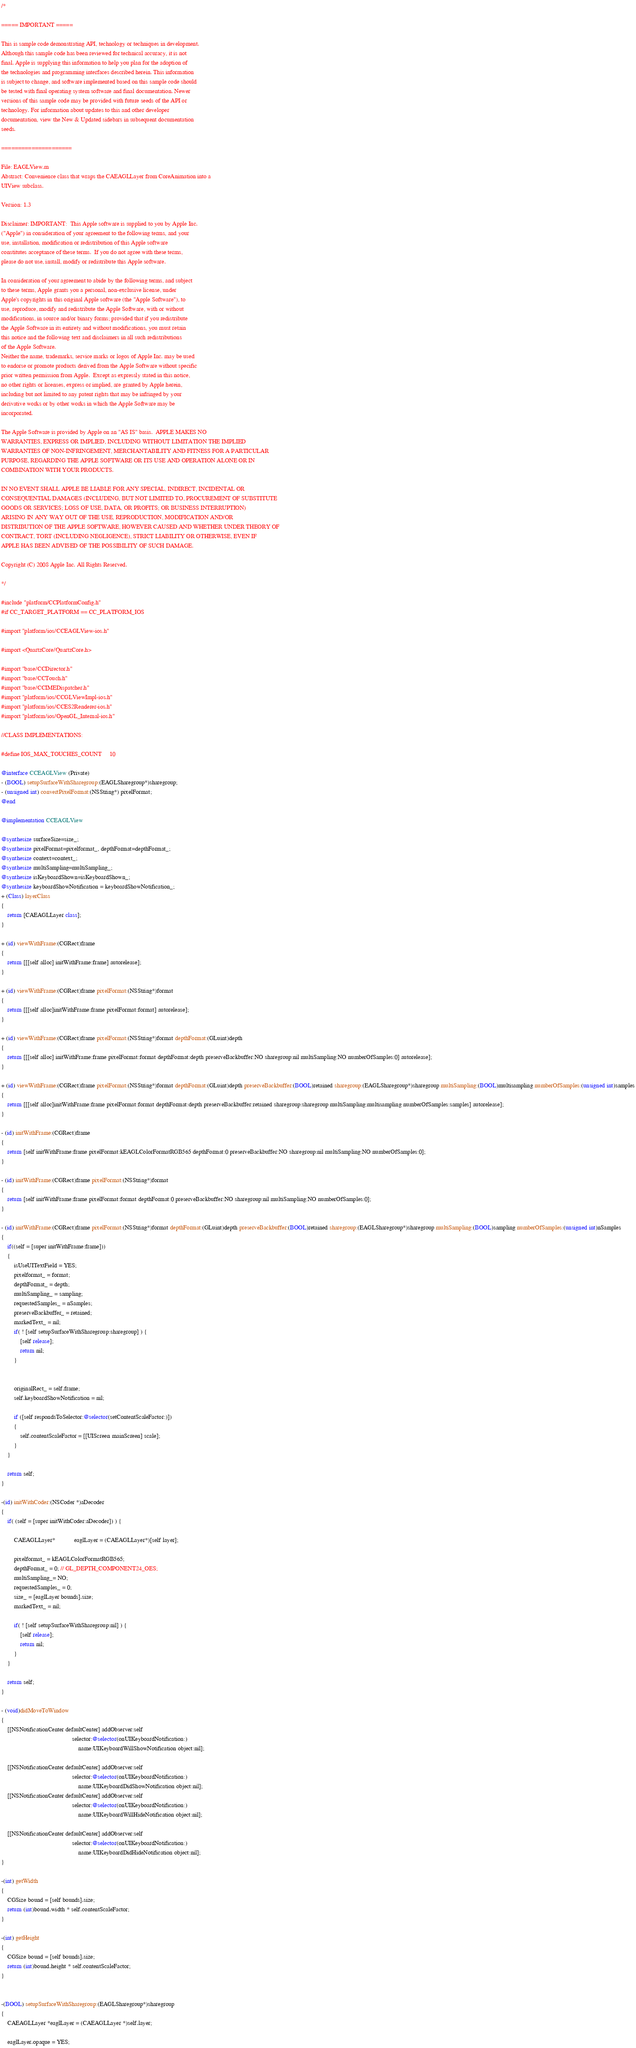<code> <loc_0><loc_0><loc_500><loc_500><_ObjectiveC_>/*

===== IMPORTANT =====

This is sample code demonstrating API, technology or techniques in development.
Although this sample code has been reviewed for technical accuracy, it is not
final. Apple is supplying this information to help you plan for the adoption of
the technologies and programming interfaces described herein. This information
is subject to change, and software implemented based on this sample code should
be tested with final operating system software and final documentation. Newer
versions of this sample code may be provided with future seeds of the API or
technology. For information about updates to this and other developer
documentation, view the New & Updated sidebars in subsequent documentation
seeds.

=====================

File: EAGLView.m
Abstract: Convenience class that wraps the CAEAGLLayer from CoreAnimation into a
UIView subclass.

Version: 1.3

Disclaimer: IMPORTANT:  This Apple software is supplied to you by Apple Inc.
("Apple") in consideration of your agreement to the following terms, and your
use, installation, modification or redistribution of this Apple software
constitutes acceptance of these terms.  If you do not agree with these terms,
please do not use, install, modify or redistribute this Apple software.

In consideration of your agreement to abide by the following terms, and subject
to these terms, Apple grants you a personal, non-exclusive license, under
Apple's copyrights in this original Apple software (the "Apple Software"), to
use, reproduce, modify and redistribute the Apple Software, with or without
modifications, in source and/or binary forms; provided that if you redistribute
the Apple Software in its entirety and without modifications, you must retain
this notice and the following text and disclaimers in all such redistributions
of the Apple Software.
Neither the name, trademarks, service marks or logos of Apple Inc. may be used
to endorse or promote products derived from the Apple Software without specific
prior written permission from Apple.  Except as expressly stated in this notice,
no other rights or licenses, express or implied, are granted by Apple herein,
including but not limited to any patent rights that may be infringed by your
derivative works or by other works in which the Apple Software may be
incorporated.

The Apple Software is provided by Apple on an "AS IS" basis.  APPLE MAKES NO
WARRANTIES, EXPRESS OR IMPLIED, INCLUDING WITHOUT LIMITATION THE IMPLIED
WARRANTIES OF NON-INFRINGEMENT, MERCHANTABILITY AND FITNESS FOR A PARTICULAR
PURPOSE, REGARDING THE APPLE SOFTWARE OR ITS USE AND OPERATION ALONE OR IN
COMBINATION WITH YOUR PRODUCTS.

IN NO EVENT SHALL APPLE BE LIABLE FOR ANY SPECIAL, INDIRECT, INCIDENTAL OR
CONSEQUENTIAL DAMAGES (INCLUDING, BUT NOT LIMITED TO, PROCUREMENT OF SUBSTITUTE
GOODS OR SERVICES; LOSS OF USE, DATA, OR PROFITS; OR BUSINESS INTERRUPTION)
ARISING IN ANY WAY OUT OF THE USE, REPRODUCTION, MODIFICATION AND/OR
DISTRIBUTION OF THE APPLE SOFTWARE, HOWEVER CAUSED AND WHETHER UNDER THEORY OF
CONTRACT, TORT (INCLUDING NEGLIGENCE), STRICT LIABILITY OR OTHERWISE, EVEN IF
APPLE HAS BEEN ADVISED OF THE POSSIBILITY OF SUCH DAMAGE.

Copyright (C) 2008 Apple Inc. All Rights Reserved.

*/

#include "platform/CCPlatformConfig.h"
#if CC_TARGET_PLATFORM == CC_PLATFORM_IOS

#import "platform/ios/CCEAGLView-ios.h"

#import <QuartzCore/QuartzCore.h>

#import "base/CCDirector.h"
#import "base/CCTouch.h"
#import "base/CCIMEDispatcher.h"
#import "platform/ios/CCGLViewImpl-ios.h"
#import "platform/ios/CCES2Renderer-ios.h"
#import "platform/ios/OpenGL_Internal-ios.h"

//CLASS IMPLEMENTATIONS:

#define IOS_MAX_TOUCHES_COUNT     10

@interface CCEAGLView (Private)
- (BOOL) setupSurfaceWithSharegroup:(EAGLSharegroup*)sharegroup;
- (unsigned int) convertPixelFormat:(NSString*) pixelFormat;
@end

@implementation CCEAGLView

@synthesize surfaceSize=size_;
@synthesize pixelFormat=pixelformat_, depthFormat=depthFormat_;
@synthesize context=context_;
@synthesize multiSampling=multiSampling_;
@synthesize isKeyboardShown=isKeyboardShown_;
@synthesize keyboardShowNotification = keyboardShowNotification_;
+ (Class) layerClass
{
    return [CAEAGLLayer class];
}

+ (id) viewWithFrame:(CGRect)frame
{
    return [[[self alloc] initWithFrame:frame] autorelease];
}

+ (id) viewWithFrame:(CGRect)frame pixelFormat:(NSString*)format
{
    return [[[self alloc]initWithFrame:frame pixelFormat:format] autorelease];
}

+ (id) viewWithFrame:(CGRect)frame pixelFormat:(NSString*)format depthFormat:(GLuint)depth
{
    return [[[self alloc] initWithFrame:frame pixelFormat:format depthFormat:depth preserveBackbuffer:NO sharegroup:nil multiSampling:NO numberOfSamples:0] autorelease];
}

+ (id) viewWithFrame:(CGRect)frame pixelFormat:(NSString*)format depthFormat:(GLuint)depth preserveBackbuffer:(BOOL)retained sharegroup:(EAGLSharegroup*)sharegroup multiSampling:(BOOL)multisampling numberOfSamples:(unsigned int)samples
{
    return [[[self alloc]initWithFrame:frame pixelFormat:format depthFormat:depth preserveBackbuffer:retained sharegroup:sharegroup multiSampling:multisampling numberOfSamples:samples] autorelease];
}

- (id) initWithFrame:(CGRect)frame
{
    return [self initWithFrame:frame pixelFormat:kEAGLColorFormatRGB565 depthFormat:0 preserveBackbuffer:NO sharegroup:nil multiSampling:NO numberOfSamples:0];
}

- (id) initWithFrame:(CGRect)frame pixelFormat:(NSString*)format 
{
    return [self initWithFrame:frame pixelFormat:format depthFormat:0 preserveBackbuffer:NO sharegroup:nil multiSampling:NO numberOfSamples:0];
}

- (id) initWithFrame:(CGRect)frame pixelFormat:(NSString*)format depthFormat:(GLuint)depth preserveBackbuffer:(BOOL)retained sharegroup:(EAGLSharegroup*)sharegroup multiSampling:(BOOL)sampling numberOfSamples:(unsigned int)nSamples
{
    if((self = [super initWithFrame:frame]))
    {
        isUseUITextField = YES;
        pixelformat_ = format;
        depthFormat_ = depth;
        multiSampling_ = sampling;
        requestedSamples_ = nSamples;
        preserveBackbuffer_ = retained;
        markedText_ = nil;
        if( ! [self setupSurfaceWithSharegroup:sharegroup] ) {
            [self release];
            return nil;
        }


        originalRect_ = self.frame;
        self.keyboardShowNotification = nil;
        
        if ([self respondsToSelector:@selector(setContentScaleFactor:)])
        {
            self.contentScaleFactor = [[UIScreen mainScreen] scale];
        }
    }
    
    return self;
}

-(id) initWithCoder:(NSCoder *)aDecoder
{
    if( (self = [super initWithCoder:aDecoder]) ) {
        
        CAEAGLLayer*            eaglLayer = (CAEAGLLayer*)[self layer];
        
        pixelformat_ = kEAGLColorFormatRGB565;
        depthFormat_ = 0; // GL_DEPTH_COMPONENT24_OES;
        multiSampling_= NO;
        requestedSamples_ = 0;
        size_ = [eaglLayer bounds].size;
        markedText_ = nil;
        
        if( ! [self setupSurfaceWithSharegroup:nil] ) {
            [self release];
            return nil;
        }
    }
    
    return self;
}

- (void)didMoveToWindow
{
    [[NSNotificationCenter defaultCenter] addObserver:self
                                             selector:@selector(onUIKeyboardNotification:)
                                                 name:UIKeyboardWillShowNotification object:nil];
    
    [[NSNotificationCenter defaultCenter] addObserver:self
                                             selector:@selector(onUIKeyboardNotification:)
                                                 name:UIKeyboardDidShowNotification object:nil];
    [[NSNotificationCenter defaultCenter] addObserver:self
                                             selector:@selector(onUIKeyboardNotification:)
                                                 name:UIKeyboardWillHideNotification object:nil];
    
    [[NSNotificationCenter defaultCenter] addObserver:self
                                             selector:@selector(onUIKeyboardNotification:)
                                                 name:UIKeyboardDidHideNotification object:nil];
}

-(int) getWidth
{
    CGSize bound = [self bounds].size;
    return (int)bound.width * self.contentScaleFactor;
}

-(int) getHeight
{
    CGSize bound = [self bounds].size;
    return (int)bound.height * self.contentScaleFactor;
}


-(BOOL) setupSurfaceWithSharegroup:(EAGLSharegroup*)sharegroup
{
    CAEAGLLayer *eaglLayer = (CAEAGLLayer *)self.layer;
    
    eaglLayer.opaque = YES;</code> 